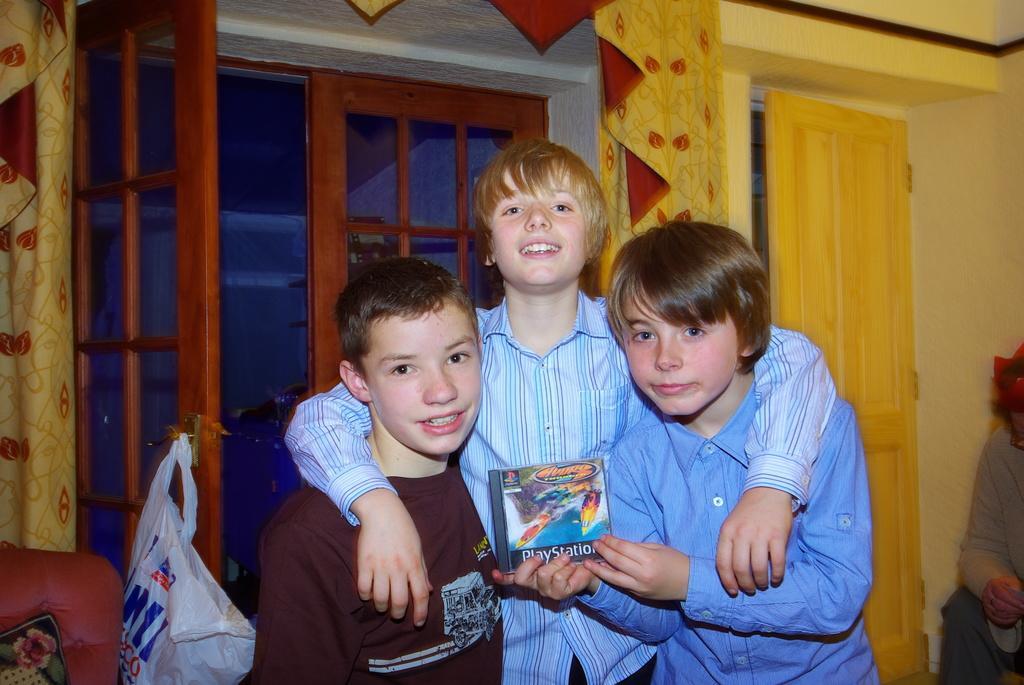Please provide a concise description of this image. There are children standing in the foreground area of the image, there are windows, curtains, a door, other objects and the polythene in the background. 